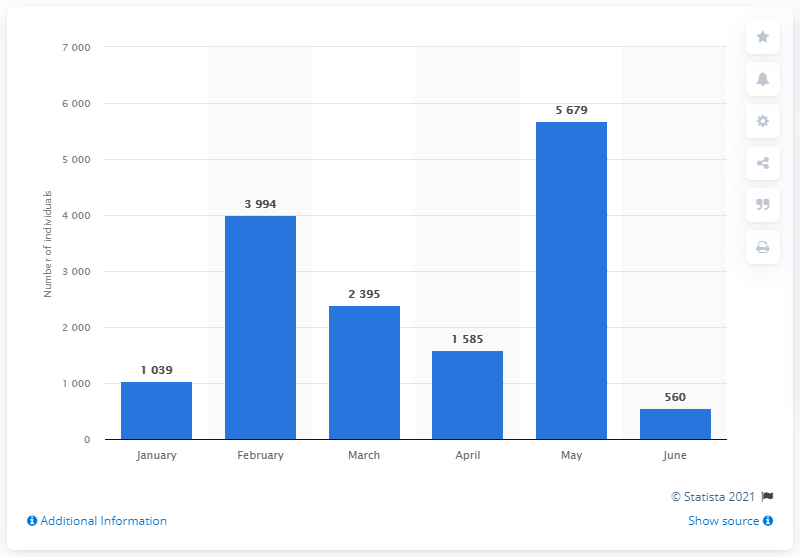List a handful of essential elements in this visual. In 2018, a total of 5,679 individuals arrived in the Italian ports of Pozzallo and Lampedusa. In May, a total of 5,679 individuals arrived in Italy by sea. 